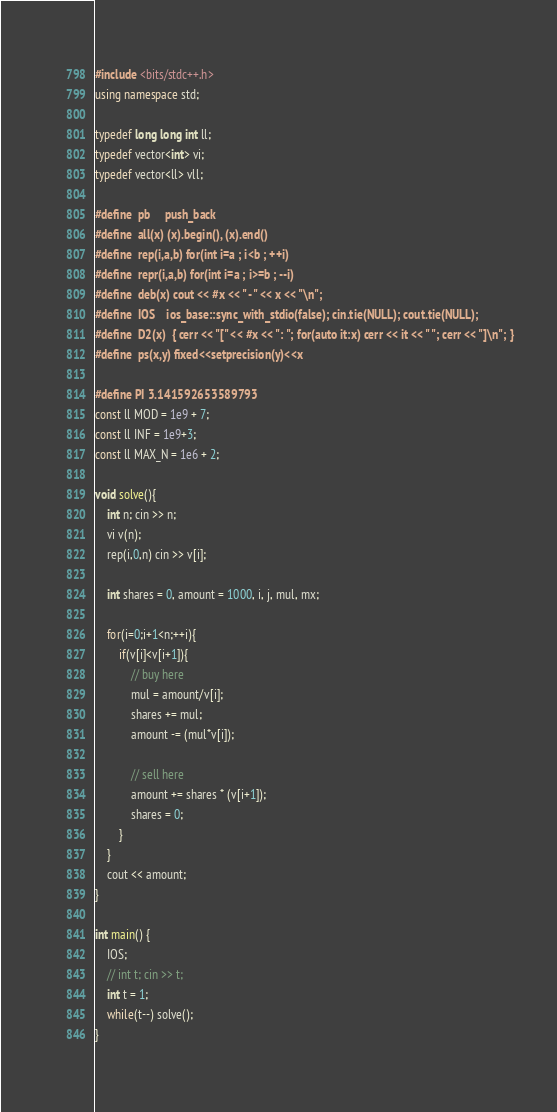<code> <loc_0><loc_0><loc_500><loc_500><_C++_>#include <bits/stdc++.h>
using namespace std;
 
typedef long long int ll;
typedef vector<int> vi;
typedef vector<ll> vll;
 
#define  pb     push_back
#define  all(x) (x).begin(), (x).end()
#define  rep(i,a,b) for(int i=a ; i<b ; ++i)
#define  repr(i,a,b) for(int i=a ; i>=b ; --i)
#define  deb(x) cout << #x << " - " << x << "\n";
#define  IOS    ios_base::sync_with_stdio(false); cin.tie(NULL); cout.tie(NULL);
#define  D2(x)  { cerr << "[" << #x << ": "; for(auto it:x) cerr << it << " "; cerr << "]\n"; }
#define  ps(x,y) fixed<<setprecision(y)<<x
 
#define PI 3.141592653589793
const ll MOD = 1e9 + 7;
const ll INF = 1e9+3;
const ll MAX_N = 1e6 + 2;

void solve(){
    int n; cin >> n;
    vi v(n);
    rep(i,0,n) cin >> v[i];
    
    int shares = 0, amount = 1000, i, j, mul, mx;
    
    for(i=0;i+1<n;++i){
        if(v[i]<v[i+1]){
            // buy here
            mul = amount/v[i];
            shares += mul;
            amount -= (mul*v[i]);
            
            // sell here
            amount += shares * (v[i+1]);
            shares = 0;
        }
    }
    cout << amount;
}
 
int main() {
    IOS;
    // int t; cin >> t;
    int t = 1; 
    while(t--) solve();
}</code> 